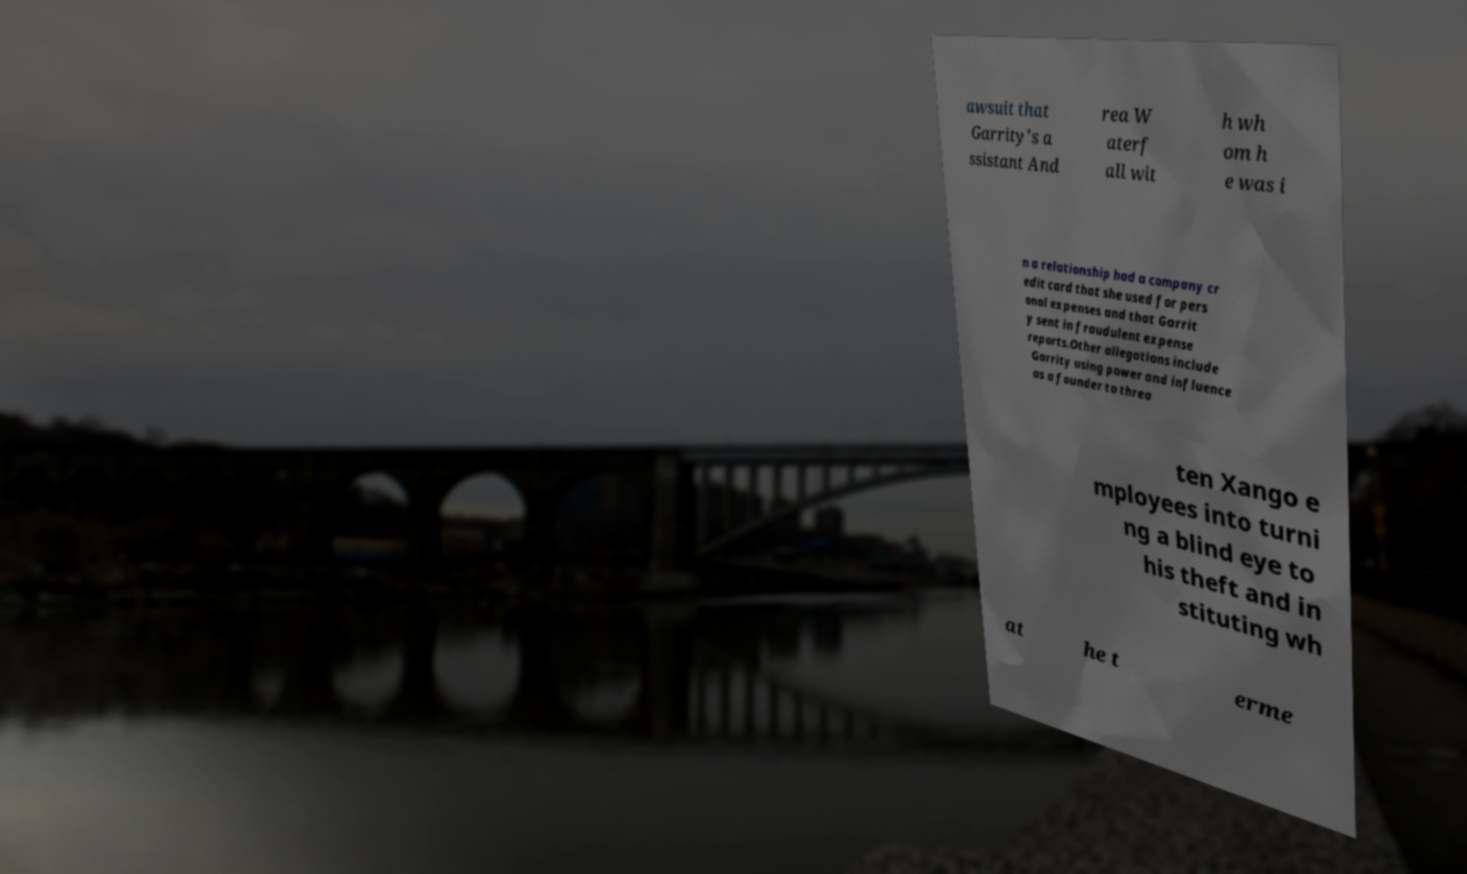Please identify and transcribe the text found in this image. awsuit that Garrity's a ssistant And rea W aterf all wit h wh om h e was i n a relationship had a company cr edit card that she used for pers onal expenses and that Garrit y sent in fraudulent expense reports.Other allegations include Garrity using power and influence as a founder to threa ten Xango e mployees into turni ng a blind eye to his theft and in stituting wh at he t erme 